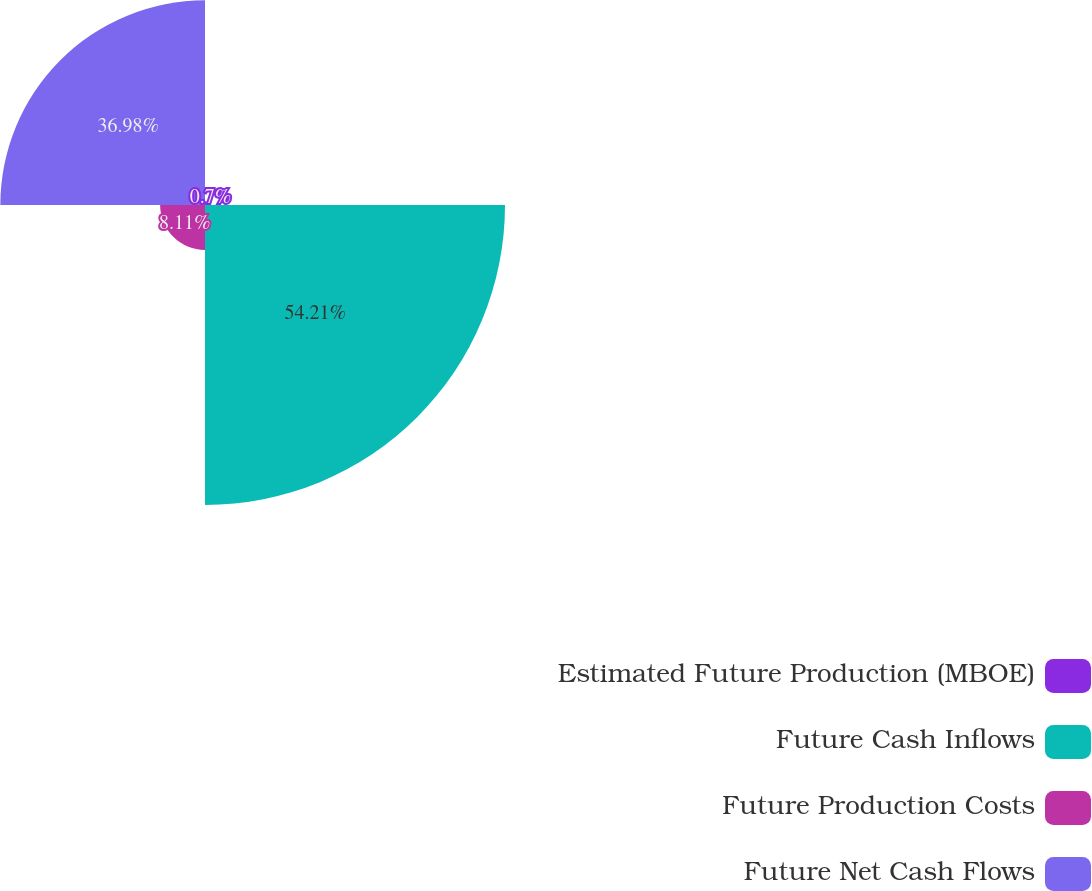<chart> <loc_0><loc_0><loc_500><loc_500><pie_chart><fcel>Estimated Future Production (MBOE)<fcel>Future Cash Inflows<fcel>Future Production Costs<fcel>Future Net Cash Flows<nl><fcel>0.7%<fcel>54.21%<fcel>8.11%<fcel>36.98%<nl></chart> 